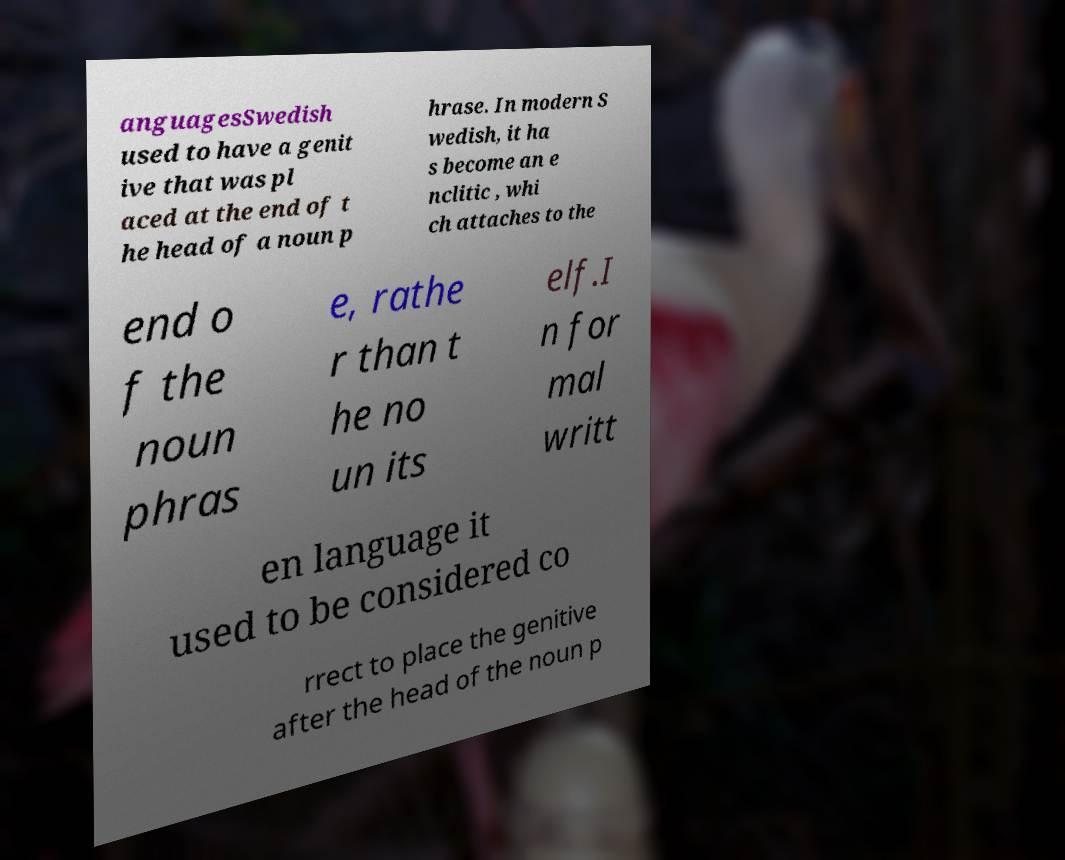Please identify and transcribe the text found in this image. anguagesSwedish used to have a genit ive that was pl aced at the end of t he head of a noun p hrase. In modern S wedish, it ha s become an e nclitic , whi ch attaches to the end o f the noun phras e, rathe r than t he no un its elf.I n for mal writt en language it used to be considered co rrect to place the genitive after the head of the noun p 